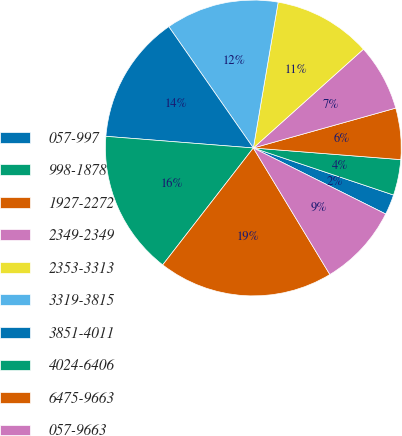<chart> <loc_0><loc_0><loc_500><loc_500><pie_chart><fcel>057-997<fcel>998-1878<fcel>1927-2272<fcel>2349-2349<fcel>2353-3313<fcel>3319-3815<fcel>3851-4011<fcel>4024-6406<fcel>6475-9663<fcel>057-9663<nl><fcel>2.21%<fcel>3.9%<fcel>5.6%<fcel>7.29%<fcel>10.68%<fcel>12.37%<fcel>14.06%<fcel>15.76%<fcel>19.15%<fcel>8.98%<nl></chart> 